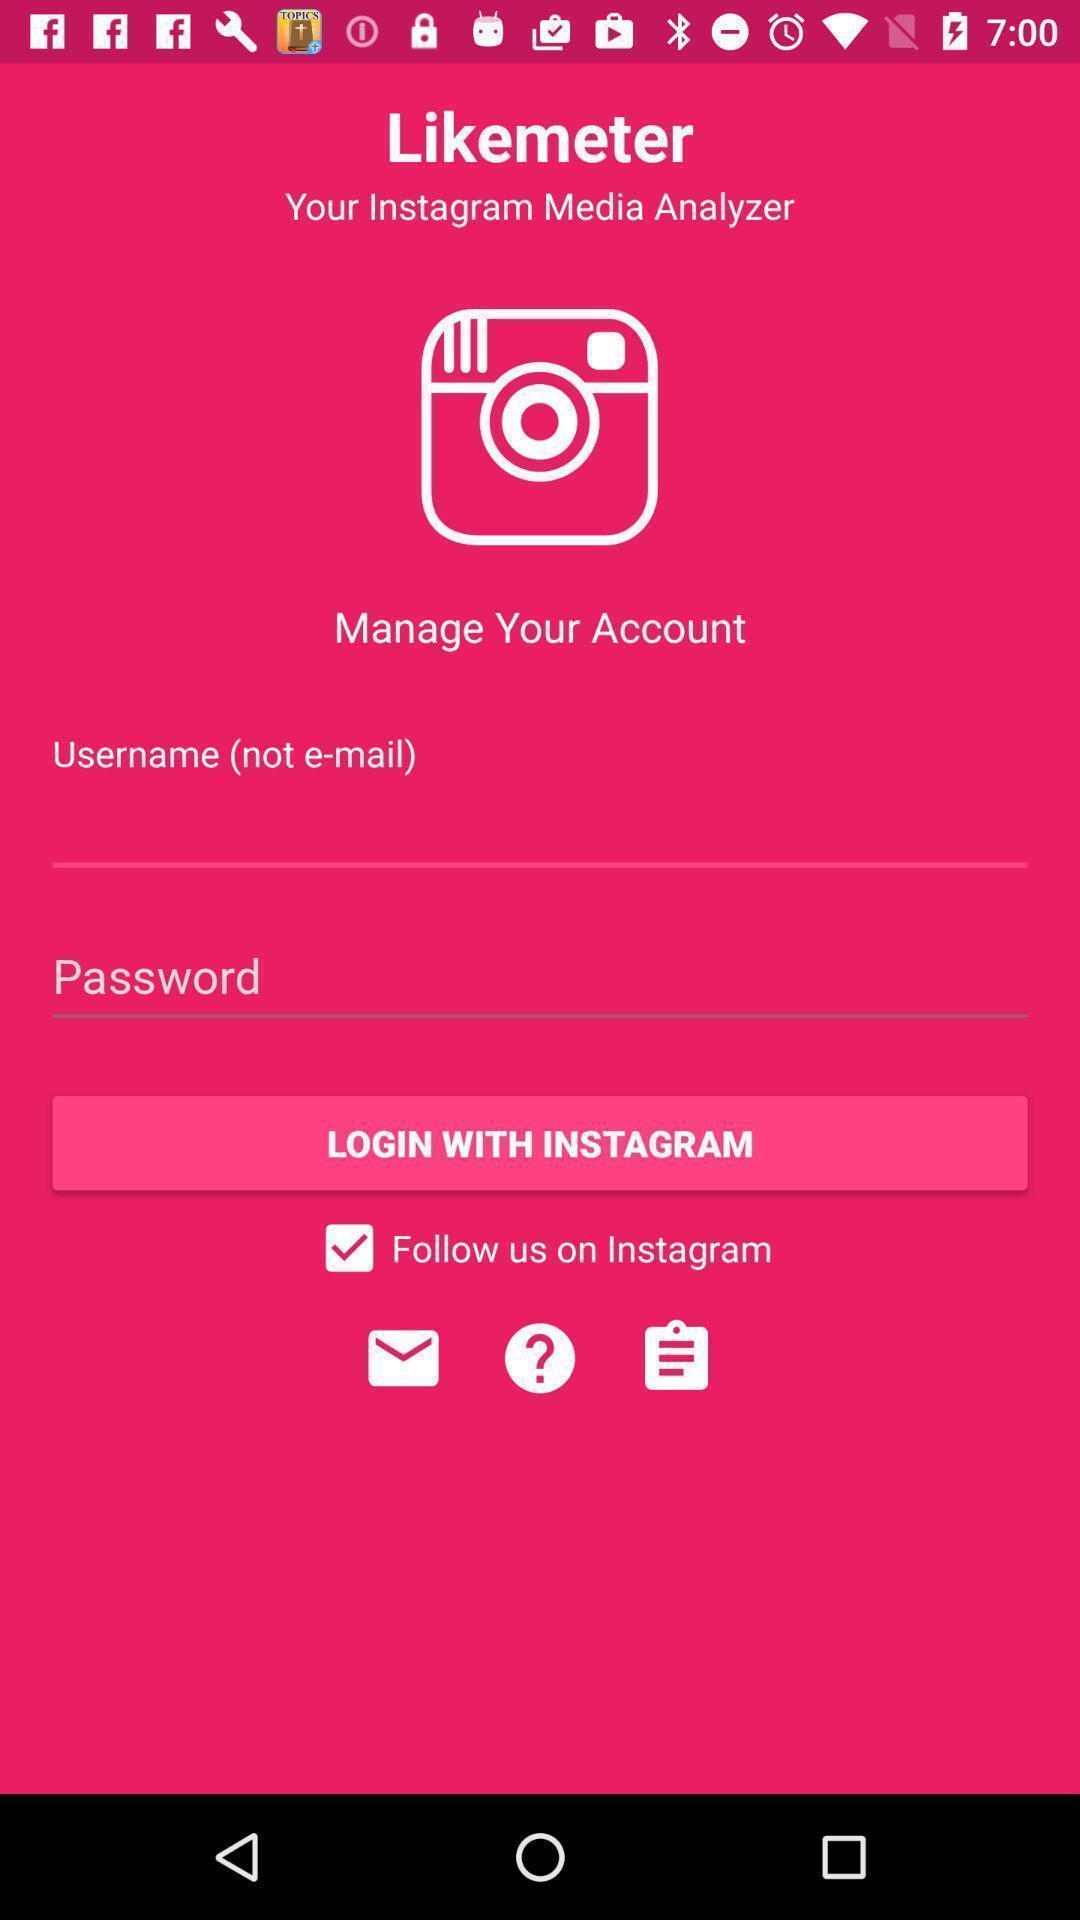Describe the content in this image. Welcome to the login page. 